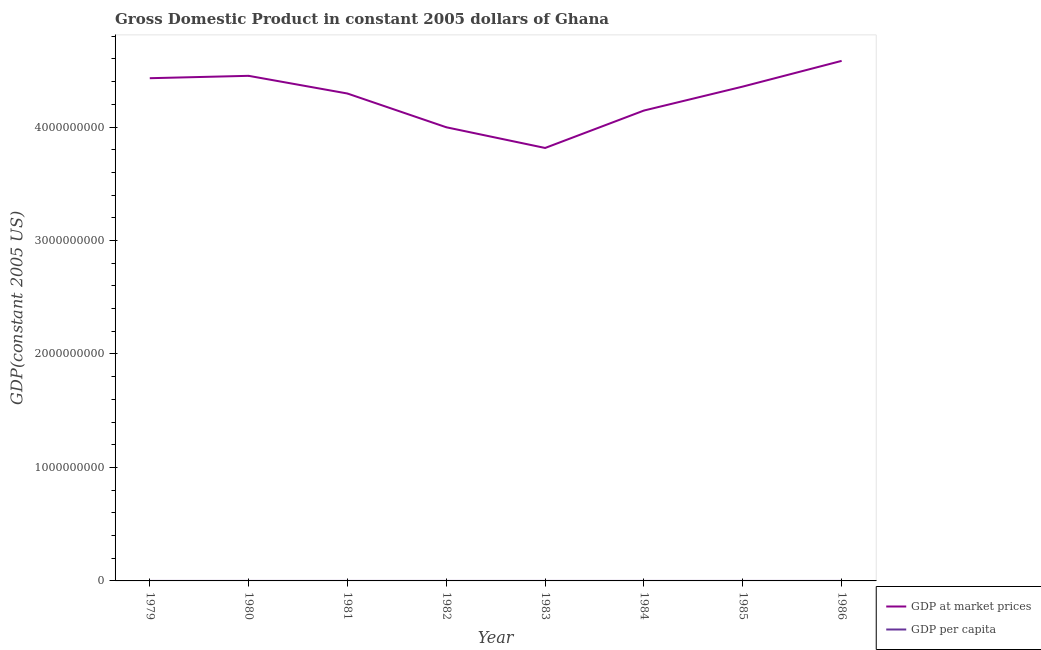How many different coloured lines are there?
Keep it short and to the point. 2. Does the line corresponding to gdp at market prices intersect with the line corresponding to gdp per capita?
Ensure brevity in your answer.  No. Is the number of lines equal to the number of legend labels?
Ensure brevity in your answer.  Yes. What is the gdp at market prices in 1986?
Provide a short and direct response. 4.58e+09. Across all years, what is the maximum gdp at market prices?
Provide a short and direct response. 4.58e+09. Across all years, what is the minimum gdp per capita?
Give a very brief answer. 320.78. In which year was the gdp per capita maximum?
Provide a succinct answer. 1979. In which year was the gdp per capita minimum?
Your response must be concise. 1983. What is the total gdp at market prices in the graph?
Offer a terse response. 3.41e+1. What is the difference between the gdp at market prices in 1981 and that in 1984?
Offer a very short reply. 1.50e+08. What is the difference between the gdp at market prices in 1980 and the gdp per capita in 1984?
Keep it short and to the point. 4.45e+09. What is the average gdp per capita per year?
Ensure brevity in your answer.  364.54. In the year 1983, what is the difference between the gdp per capita and gdp at market prices?
Your answer should be very brief. -3.82e+09. In how many years, is the gdp per capita greater than 3000000000 US$?
Make the answer very short. 0. What is the ratio of the gdp at market prices in 1982 to that in 1985?
Keep it short and to the point. 0.92. What is the difference between the highest and the second highest gdp per capita?
Your response must be concise. 7.83. What is the difference between the highest and the lowest gdp at market prices?
Make the answer very short. 7.68e+08. Is the sum of the gdp per capita in 1979 and 1983 greater than the maximum gdp at market prices across all years?
Offer a terse response. No. Does the gdp at market prices monotonically increase over the years?
Your response must be concise. No. Is the gdp per capita strictly less than the gdp at market prices over the years?
Your answer should be very brief. Yes. What is the difference between two consecutive major ticks on the Y-axis?
Your answer should be compact. 1.00e+09. How are the legend labels stacked?
Ensure brevity in your answer.  Vertical. What is the title of the graph?
Offer a terse response. Gross Domestic Product in constant 2005 dollars of Ghana. Does "Domestic Liabilities" appear as one of the legend labels in the graph?
Your response must be concise. No. What is the label or title of the X-axis?
Offer a very short reply. Year. What is the label or title of the Y-axis?
Your answer should be very brief. GDP(constant 2005 US). What is the GDP(constant 2005 US) of GDP at market prices in 1979?
Ensure brevity in your answer.  4.43e+09. What is the GDP(constant 2005 US) in GDP per capita in 1979?
Provide a short and direct response. 419.94. What is the GDP(constant 2005 US) in GDP at market prices in 1980?
Make the answer very short. 4.45e+09. What is the GDP(constant 2005 US) of GDP per capita in 1980?
Offer a very short reply. 412.1. What is the GDP(constant 2005 US) in GDP at market prices in 1981?
Offer a terse response. 4.30e+09. What is the GDP(constant 2005 US) of GDP per capita in 1981?
Give a very brief answer. 386.38. What is the GDP(constant 2005 US) in GDP at market prices in 1982?
Offer a very short reply. 4.00e+09. What is the GDP(constant 2005 US) of GDP per capita in 1982?
Offer a very short reply. 348.03. What is the GDP(constant 2005 US) of GDP at market prices in 1983?
Provide a short and direct response. 3.82e+09. What is the GDP(constant 2005 US) of GDP per capita in 1983?
Keep it short and to the point. 320.78. What is the GDP(constant 2005 US) of GDP at market prices in 1984?
Make the answer very short. 4.15e+09. What is the GDP(constant 2005 US) of GDP per capita in 1984?
Make the answer very short. 336.74. What is the GDP(constant 2005 US) in GDP at market prices in 1985?
Your answer should be compact. 4.36e+09. What is the GDP(constant 2005 US) in GDP per capita in 1985?
Ensure brevity in your answer.  342.62. What is the GDP(constant 2005 US) in GDP at market prices in 1986?
Provide a short and direct response. 4.58e+09. What is the GDP(constant 2005 US) of GDP per capita in 1986?
Your answer should be compact. 349.76. Across all years, what is the maximum GDP(constant 2005 US) in GDP at market prices?
Make the answer very short. 4.58e+09. Across all years, what is the maximum GDP(constant 2005 US) in GDP per capita?
Provide a short and direct response. 419.94. Across all years, what is the minimum GDP(constant 2005 US) in GDP at market prices?
Give a very brief answer. 3.82e+09. Across all years, what is the minimum GDP(constant 2005 US) in GDP per capita?
Ensure brevity in your answer.  320.78. What is the total GDP(constant 2005 US) in GDP at market prices in the graph?
Offer a very short reply. 3.41e+1. What is the total GDP(constant 2005 US) in GDP per capita in the graph?
Offer a very short reply. 2916.36. What is the difference between the GDP(constant 2005 US) of GDP at market prices in 1979 and that in 1980?
Offer a very short reply. -2.09e+07. What is the difference between the GDP(constant 2005 US) of GDP per capita in 1979 and that in 1980?
Give a very brief answer. 7.83. What is the difference between the GDP(constant 2005 US) in GDP at market prices in 1979 and that in 1981?
Make the answer very short. 1.35e+08. What is the difference between the GDP(constant 2005 US) of GDP per capita in 1979 and that in 1981?
Offer a terse response. 33.56. What is the difference between the GDP(constant 2005 US) of GDP at market prices in 1979 and that in 1982?
Provide a succinct answer. 4.32e+08. What is the difference between the GDP(constant 2005 US) in GDP per capita in 1979 and that in 1982?
Your answer should be very brief. 71.91. What is the difference between the GDP(constant 2005 US) in GDP at market prices in 1979 and that in 1983?
Give a very brief answer. 6.15e+08. What is the difference between the GDP(constant 2005 US) of GDP per capita in 1979 and that in 1983?
Your answer should be very brief. 99.16. What is the difference between the GDP(constant 2005 US) in GDP at market prices in 1979 and that in 1984?
Keep it short and to the point. 2.85e+08. What is the difference between the GDP(constant 2005 US) of GDP per capita in 1979 and that in 1984?
Keep it short and to the point. 83.19. What is the difference between the GDP(constant 2005 US) in GDP at market prices in 1979 and that in 1985?
Give a very brief answer. 7.39e+07. What is the difference between the GDP(constant 2005 US) in GDP per capita in 1979 and that in 1985?
Offer a very short reply. 77.32. What is the difference between the GDP(constant 2005 US) in GDP at market prices in 1979 and that in 1986?
Provide a short and direct response. -1.53e+08. What is the difference between the GDP(constant 2005 US) of GDP per capita in 1979 and that in 1986?
Your answer should be very brief. 70.17. What is the difference between the GDP(constant 2005 US) in GDP at market prices in 1980 and that in 1981?
Offer a terse response. 1.56e+08. What is the difference between the GDP(constant 2005 US) of GDP per capita in 1980 and that in 1981?
Your answer should be very brief. 25.72. What is the difference between the GDP(constant 2005 US) in GDP at market prices in 1980 and that in 1982?
Your answer should be very brief. 4.53e+08. What is the difference between the GDP(constant 2005 US) of GDP per capita in 1980 and that in 1982?
Provide a succinct answer. 64.07. What is the difference between the GDP(constant 2005 US) in GDP at market prices in 1980 and that in 1983?
Ensure brevity in your answer.  6.36e+08. What is the difference between the GDP(constant 2005 US) of GDP per capita in 1980 and that in 1983?
Provide a short and direct response. 91.32. What is the difference between the GDP(constant 2005 US) in GDP at market prices in 1980 and that in 1984?
Offer a terse response. 3.06e+08. What is the difference between the GDP(constant 2005 US) of GDP per capita in 1980 and that in 1984?
Provide a short and direct response. 75.36. What is the difference between the GDP(constant 2005 US) in GDP at market prices in 1980 and that in 1985?
Ensure brevity in your answer.  9.48e+07. What is the difference between the GDP(constant 2005 US) in GDP per capita in 1980 and that in 1985?
Provide a short and direct response. 69.49. What is the difference between the GDP(constant 2005 US) of GDP at market prices in 1980 and that in 1986?
Ensure brevity in your answer.  -1.32e+08. What is the difference between the GDP(constant 2005 US) in GDP per capita in 1980 and that in 1986?
Offer a terse response. 62.34. What is the difference between the GDP(constant 2005 US) of GDP at market prices in 1981 and that in 1982?
Your answer should be compact. 2.97e+08. What is the difference between the GDP(constant 2005 US) in GDP per capita in 1981 and that in 1982?
Your answer should be compact. 38.35. What is the difference between the GDP(constant 2005 US) of GDP at market prices in 1981 and that in 1983?
Provide a succinct answer. 4.80e+08. What is the difference between the GDP(constant 2005 US) of GDP per capita in 1981 and that in 1983?
Your response must be concise. 65.6. What is the difference between the GDP(constant 2005 US) in GDP at market prices in 1981 and that in 1984?
Offer a very short reply. 1.50e+08. What is the difference between the GDP(constant 2005 US) in GDP per capita in 1981 and that in 1984?
Ensure brevity in your answer.  49.64. What is the difference between the GDP(constant 2005 US) of GDP at market prices in 1981 and that in 1985?
Keep it short and to the point. -6.12e+07. What is the difference between the GDP(constant 2005 US) in GDP per capita in 1981 and that in 1985?
Provide a short and direct response. 43.76. What is the difference between the GDP(constant 2005 US) of GDP at market prices in 1981 and that in 1986?
Provide a short and direct response. -2.88e+08. What is the difference between the GDP(constant 2005 US) of GDP per capita in 1981 and that in 1986?
Ensure brevity in your answer.  36.62. What is the difference between the GDP(constant 2005 US) of GDP at market prices in 1982 and that in 1983?
Provide a short and direct response. 1.82e+08. What is the difference between the GDP(constant 2005 US) in GDP per capita in 1982 and that in 1983?
Your answer should be compact. 27.25. What is the difference between the GDP(constant 2005 US) of GDP at market prices in 1982 and that in 1984?
Offer a very short reply. -1.48e+08. What is the difference between the GDP(constant 2005 US) of GDP per capita in 1982 and that in 1984?
Keep it short and to the point. 11.29. What is the difference between the GDP(constant 2005 US) in GDP at market prices in 1982 and that in 1985?
Make the answer very short. -3.59e+08. What is the difference between the GDP(constant 2005 US) of GDP per capita in 1982 and that in 1985?
Offer a very short reply. 5.41. What is the difference between the GDP(constant 2005 US) in GDP at market prices in 1982 and that in 1986?
Your response must be concise. -5.85e+08. What is the difference between the GDP(constant 2005 US) of GDP per capita in 1982 and that in 1986?
Offer a very short reply. -1.73. What is the difference between the GDP(constant 2005 US) in GDP at market prices in 1983 and that in 1984?
Give a very brief answer. -3.30e+08. What is the difference between the GDP(constant 2005 US) in GDP per capita in 1983 and that in 1984?
Keep it short and to the point. -15.96. What is the difference between the GDP(constant 2005 US) in GDP at market prices in 1983 and that in 1985?
Your answer should be compact. -5.41e+08. What is the difference between the GDP(constant 2005 US) of GDP per capita in 1983 and that in 1985?
Make the answer very short. -21.83. What is the difference between the GDP(constant 2005 US) in GDP at market prices in 1983 and that in 1986?
Provide a short and direct response. -7.68e+08. What is the difference between the GDP(constant 2005 US) in GDP per capita in 1983 and that in 1986?
Provide a succinct answer. -28.98. What is the difference between the GDP(constant 2005 US) in GDP at market prices in 1984 and that in 1985?
Make the answer very short. -2.11e+08. What is the difference between the GDP(constant 2005 US) in GDP per capita in 1984 and that in 1985?
Your response must be concise. -5.87. What is the difference between the GDP(constant 2005 US) of GDP at market prices in 1984 and that in 1986?
Offer a terse response. -4.38e+08. What is the difference between the GDP(constant 2005 US) of GDP per capita in 1984 and that in 1986?
Keep it short and to the point. -13.02. What is the difference between the GDP(constant 2005 US) of GDP at market prices in 1985 and that in 1986?
Keep it short and to the point. -2.27e+08. What is the difference between the GDP(constant 2005 US) in GDP per capita in 1985 and that in 1986?
Provide a succinct answer. -7.15. What is the difference between the GDP(constant 2005 US) of GDP at market prices in 1979 and the GDP(constant 2005 US) of GDP per capita in 1980?
Give a very brief answer. 4.43e+09. What is the difference between the GDP(constant 2005 US) in GDP at market prices in 1979 and the GDP(constant 2005 US) in GDP per capita in 1981?
Your answer should be very brief. 4.43e+09. What is the difference between the GDP(constant 2005 US) of GDP at market prices in 1979 and the GDP(constant 2005 US) of GDP per capita in 1982?
Keep it short and to the point. 4.43e+09. What is the difference between the GDP(constant 2005 US) of GDP at market prices in 1979 and the GDP(constant 2005 US) of GDP per capita in 1983?
Provide a succinct answer. 4.43e+09. What is the difference between the GDP(constant 2005 US) in GDP at market prices in 1979 and the GDP(constant 2005 US) in GDP per capita in 1984?
Give a very brief answer. 4.43e+09. What is the difference between the GDP(constant 2005 US) of GDP at market prices in 1979 and the GDP(constant 2005 US) of GDP per capita in 1985?
Offer a terse response. 4.43e+09. What is the difference between the GDP(constant 2005 US) of GDP at market prices in 1979 and the GDP(constant 2005 US) of GDP per capita in 1986?
Give a very brief answer. 4.43e+09. What is the difference between the GDP(constant 2005 US) of GDP at market prices in 1980 and the GDP(constant 2005 US) of GDP per capita in 1981?
Make the answer very short. 4.45e+09. What is the difference between the GDP(constant 2005 US) of GDP at market prices in 1980 and the GDP(constant 2005 US) of GDP per capita in 1982?
Your response must be concise. 4.45e+09. What is the difference between the GDP(constant 2005 US) in GDP at market prices in 1980 and the GDP(constant 2005 US) in GDP per capita in 1983?
Provide a short and direct response. 4.45e+09. What is the difference between the GDP(constant 2005 US) of GDP at market prices in 1980 and the GDP(constant 2005 US) of GDP per capita in 1984?
Offer a very short reply. 4.45e+09. What is the difference between the GDP(constant 2005 US) of GDP at market prices in 1980 and the GDP(constant 2005 US) of GDP per capita in 1985?
Keep it short and to the point. 4.45e+09. What is the difference between the GDP(constant 2005 US) of GDP at market prices in 1980 and the GDP(constant 2005 US) of GDP per capita in 1986?
Your answer should be very brief. 4.45e+09. What is the difference between the GDP(constant 2005 US) of GDP at market prices in 1981 and the GDP(constant 2005 US) of GDP per capita in 1982?
Make the answer very short. 4.30e+09. What is the difference between the GDP(constant 2005 US) in GDP at market prices in 1981 and the GDP(constant 2005 US) in GDP per capita in 1983?
Provide a short and direct response. 4.30e+09. What is the difference between the GDP(constant 2005 US) in GDP at market prices in 1981 and the GDP(constant 2005 US) in GDP per capita in 1984?
Your answer should be very brief. 4.30e+09. What is the difference between the GDP(constant 2005 US) of GDP at market prices in 1981 and the GDP(constant 2005 US) of GDP per capita in 1985?
Ensure brevity in your answer.  4.30e+09. What is the difference between the GDP(constant 2005 US) of GDP at market prices in 1981 and the GDP(constant 2005 US) of GDP per capita in 1986?
Ensure brevity in your answer.  4.30e+09. What is the difference between the GDP(constant 2005 US) in GDP at market prices in 1982 and the GDP(constant 2005 US) in GDP per capita in 1983?
Your answer should be very brief. 4.00e+09. What is the difference between the GDP(constant 2005 US) of GDP at market prices in 1982 and the GDP(constant 2005 US) of GDP per capita in 1984?
Provide a short and direct response. 4.00e+09. What is the difference between the GDP(constant 2005 US) of GDP at market prices in 1982 and the GDP(constant 2005 US) of GDP per capita in 1985?
Your answer should be compact. 4.00e+09. What is the difference between the GDP(constant 2005 US) in GDP at market prices in 1982 and the GDP(constant 2005 US) in GDP per capita in 1986?
Ensure brevity in your answer.  4.00e+09. What is the difference between the GDP(constant 2005 US) of GDP at market prices in 1983 and the GDP(constant 2005 US) of GDP per capita in 1984?
Provide a succinct answer. 3.82e+09. What is the difference between the GDP(constant 2005 US) of GDP at market prices in 1983 and the GDP(constant 2005 US) of GDP per capita in 1985?
Your answer should be compact. 3.82e+09. What is the difference between the GDP(constant 2005 US) of GDP at market prices in 1983 and the GDP(constant 2005 US) of GDP per capita in 1986?
Your response must be concise. 3.82e+09. What is the difference between the GDP(constant 2005 US) in GDP at market prices in 1984 and the GDP(constant 2005 US) in GDP per capita in 1985?
Offer a very short reply. 4.15e+09. What is the difference between the GDP(constant 2005 US) of GDP at market prices in 1984 and the GDP(constant 2005 US) of GDP per capita in 1986?
Your answer should be very brief. 4.15e+09. What is the difference between the GDP(constant 2005 US) of GDP at market prices in 1985 and the GDP(constant 2005 US) of GDP per capita in 1986?
Offer a very short reply. 4.36e+09. What is the average GDP(constant 2005 US) of GDP at market prices per year?
Offer a very short reply. 4.26e+09. What is the average GDP(constant 2005 US) of GDP per capita per year?
Your answer should be very brief. 364.54. In the year 1979, what is the difference between the GDP(constant 2005 US) of GDP at market prices and GDP(constant 2005 US) of GDP per capita?
Give a very brief answer. 4.43e+09. In the year 1980, what is the difference between the GDP(constant 2005 US) of GDP at market prices and GDP(constant 2005 US) of GDP per capita?
Your answer should be very brief. 4.45e+09. In the year 1981, what is the difference between the GDP(constant 2005 US) of GDP at market prices and GDP(constant 2005 US) of GDP per capita?
Provide a succinct answer. 4.30e+09. In the year 1982, what is the difference between the GDP(constant 2005 US) in GDP at market prices and GDP(constant 2005 US) in GDP per capita?
Provide a succinct answer. 4.00e+09. In the year 1983, what is the difference between the GDP(constant 2005 US) in GDP at market prices and GDP(constant 2005 US) in GDP per capita?
Offer a very short reply. 3.82e+09. In the year 1984, what is the difference between the GDP(constant 2005 US) of GDP at market prices and GDP(constant 2005 US) of GDP per capita?
Offer a terse response. 4.15e+09. In the year 1985, what is the difference between the GDP(constant 2005 US) in GDP at market prices and GDP(constant 2005 US) in GDP per capita?
Provide a succinct answer. 4.36e+09. In the year 1986, what is the difference between the GDP(constant 2005 US) of GDP at market prices and GDP(constant 2005 US) of GDP per capita?
Provide a succinct answer. 4.58e+09. What is the ratio of the GDP(constant 2005 US) of GDP at market prices in 1979 to that in 1980?
Provide a succinct answer. 1. What is the ratio of the GDP(constant 2005 US) in GDP per capita in 1979 to that in 1980?
Give a very brief answer. 1.02. What is the ratio of the GDP(constant 2005 US) in GDP at market prices in 1979 to that in 1981?
Provide a short and direct response. 1.03. What is the ratio of the GDP(constant 2005 US) in GDP per capita in 1979 to that in 1981?
Give a very brief answer. 1.09. What is the ratio of the GDP(constant 2005 US) of GDP at market prices in 1979 to that in 1982?
Make the answer very short. 1.11. What is the ratio of the GDP(constant 2005 US) in GDP per capita in 1979 to that in 1982?
Your answer should be compact. 1.21. What is the ratio of the GDP(constant 2005 US) in GDP at market prices in 1979 to that in 1983?
Your answer should be compact. 1.16. What is the ratio of the GDP(constant 2005 US) in GDP per capita in 1979 to that in 1983?
Your answer should be compact. 1.31. What is the ratio of the GDP(constant 2005 US) in GDP at market prices in 1979 to that in 1984?
Give a very brief answer. 1.07. What is the ratio of the GDP(constant 2005 US) of GDP per capita in 1979 to that in 1984?
Offer a very short reply. 1.25. What is the ratio of the GDP(constant 2005 US) of GDP at market prices in 1979 to that in 1985?
Your answer should be compact. 1.02. What is the ratio of the GDP(constant 2005 US) of GDP per capita in 1979 to that in 1985?
Offer a terse response. 1.23. What is the ratio of the GDP(constant 2005 US) in GDP at market prices in 1979 to that in 1986?
Keep it short and to the point. 0.97. What is the ratio of the GDP(constant 2005 US) in GDP per capita in 1979 to that in 1986?
Keep it short and to the point. 1.2. What is the ratio of the GDP(constant 2005 US) of GDP at market prices in 1980 to that in 1981?
Your answer should be very brief. 1.04. What is the ratio of the GDP(constant 2005 US) of GDP per capita in 1980 to that in 1981?
Offer a very short reply. 1.07. What is the ratio of the GDP(constant 2005 US) of GDP at market prices in 1980 to that in 1982?
Offer a very short reply. 1.11. What is the ratio of the GDP(constant 2005 US) of GDP per capita in 1980 to that in 1982?
Offer a terse response. 1.18. What is the ratio of the GDP(constant 2005 US) of GDP at market prices in 1980 to that in 1983?
Keep it short and to the point. 1.17. What is the ratio of the GDP(constant 2005 US) of GDP per capita in 1980 to that in 1983?
Your answer should be compact. 1.28. What is the ratio of the GDP(constant 2005 US) of GDP at market prices in 1980 to that in 1984?
Offer a terse response. 1.07. What is the ratio of the GDP(constant 2005 US) in GDP per capita in 1980 to that in 1984?
Provide a succinct answer. 1.22. What is the ratio of the GDP(constant 2005 US) of GDP at market prices in 1980 to that in 1985?
Ensure brevity in your answer.  1.02. What is the ratio of the GDP(constant 2005 US) of GDP per capita in 1980 to that in 1985?
Your answer should be very brief. 1.2. What is the ratio of the GDP(constant 2005 US) of GDP at market prices in 1980 to that in 1986?
Offer a very short reply. 0.97. What is the ratio of the GDP(constant 2005 US) in GDP per capita in 1980 to that in 1986?
Your answer should be very brief. 1.18. What is the ratio of the GDP(constant 2005 US) in GDP at market prices in 1981 to that in 1982?
Keep it short and to the point. 1.07. What is the ratio of the GDP(constant 2005 US) in GDP per capita in 1981 to that in 1982?
Your answer should be very brief. 1.11. What is the ratio of the GDP(constant 2005 US) in GDP at market prices in 1981 to that in 1983?
Make the answer very short. 1.13. What is the ratio of the GDP(constant 2005 US) in GDP per capita in 1981 to that in 1983?
Your answer should be compact. 1.2. What is the ratio of the GDP(constant 2005 US) in GDP at market prices in 1981 to that in 1984?
Give a very brief answer. 1.04. What is the ratio of the GDP(constant 2005 US) of GDP per capita in 1981 to that in 1984?
Make the answer very short. 1.15. What is the ratio of the GDP(constant 2005 US) of GDP at market prices in 1981 to that in 1985?
Offer a terse response. 0.99. What is the ratio of the GDP(constant 2005 US) of GDP per capita in 1981 to that in 1985?
Provide a succinct answer. 1.13. What is the ratio of the GDP(constant 2005 US) of GDP at market prices in 1981 to that in 1986?
Your answer should be very brief. 0.94. What is the ratio of the GDP(constant 2005 US) in GDP per capita in 1981 to that in 1986?
Provide a short and direct response. 1.1. What is the ratio of the GDP(constant 2005 US) in GDP at market prices in 1982 to that in 1983?
Your response must be concise. 1.05. What is the ratio of the GDP(constant 2005 US) of GDP per capita in 1982 to that in 1983?
Your response must be concise. 1.08. What is the ratio of the GDP(constant 2005 US) of GDP at market prices in 1982 to that in 1984?
Keep it short and to the point. 0.96. What is the ratio of the GDP(constant 2005 US) of GDP per capita in 1982 to that in 1984?
Your answer should be very brief. 1.03. What is the ratio of the GDP(constant 2005 US) in GDP at market prices in 1982 to that in 1985?
Your response must be concise. 0.92. What is the ratio of the GDP(constant 2005 US) in GDP per capita in 1982 to that in 1985?
Your response must be concise. 1.02. What is the ratio of the GDP(constant 2005 US) in GDP at market prices in 1982 to that in 1986?
Provide a short and direct response. 0.87. What is the ratio of the GDP(constant 2005 US) of GDP at market prices in 1983 to that in 1984?
Your answer should be compact. 0.92. What is the ratio of the GDP(constant 2005 US) of GDP per capita in 1983 to that in 1984?
Your answer should be compact. 0.95. What is the ratio of the GDP(constant 2005 US) of GDP at market prices in 1983 to that in 1985?
Your answer should be very brief. 0.88. What is the ratio of the GDP(constant 2005 US) of GDP per capita in 1983 to that in 1985?
Provide a short and direct response. 0.94. What is the ratio of the GDP(constant 2005 US) in GDP at market prices in 1983 to that in 1986?
Your response must be concise. 0.83. What is the ratio of the GDP(constant 2005 US) in GDP per capita in 1983 to that in 1986?
Ensure brevity in your answer.  0.92. What is the ratio of the GDP(constant 2005 US) of GDP at market prices in 1984 to that in 1985?
Provide a short and direct response. 0.95. What is the ratio of the GDP(constant 2005 US) in GDP per capita in 1984 to that in 1985?
Ensure brevity in your answer.  0.98. What is the ratio of the GDP(constant 2005 US) in GDP at market prices in 1984 to that in 1986?
Provide a short and direct response. 0.9. What is the ratio of the GDP(constant 2005 US) of GDP per capita in 1984 to that in 1986?
Your answer should be compact. 0.96. What is the ratio of the GDP(constant 2005 US) of GDP at market prices in 1985 to that in 1986?
Your response must be concise. 0.95. What is the ratio of the GDP(constant 2005 US) of GDP per capita in 1985 to that in 1986?
Provide a succinct answer. 0.98. What is the difference between the highest and the second highest GDP(constant 2005 US) of GDP at market prices?
Your response must be concise. 1.32e+08. What is the difference between the highest and the second highest GDP(constant 2005 US) of GDP per capita?
Your answer should be compact. 7.83. What is the difference between the highest and the lowest GDP(constant 2005 US) in GDP at market prices?
Your answer should be compact. 7.68e+08. What is the difference between the highest and the lowest GDP(constant 2005 US) in GDP per capita?
Your response must be concise. 99.16. 